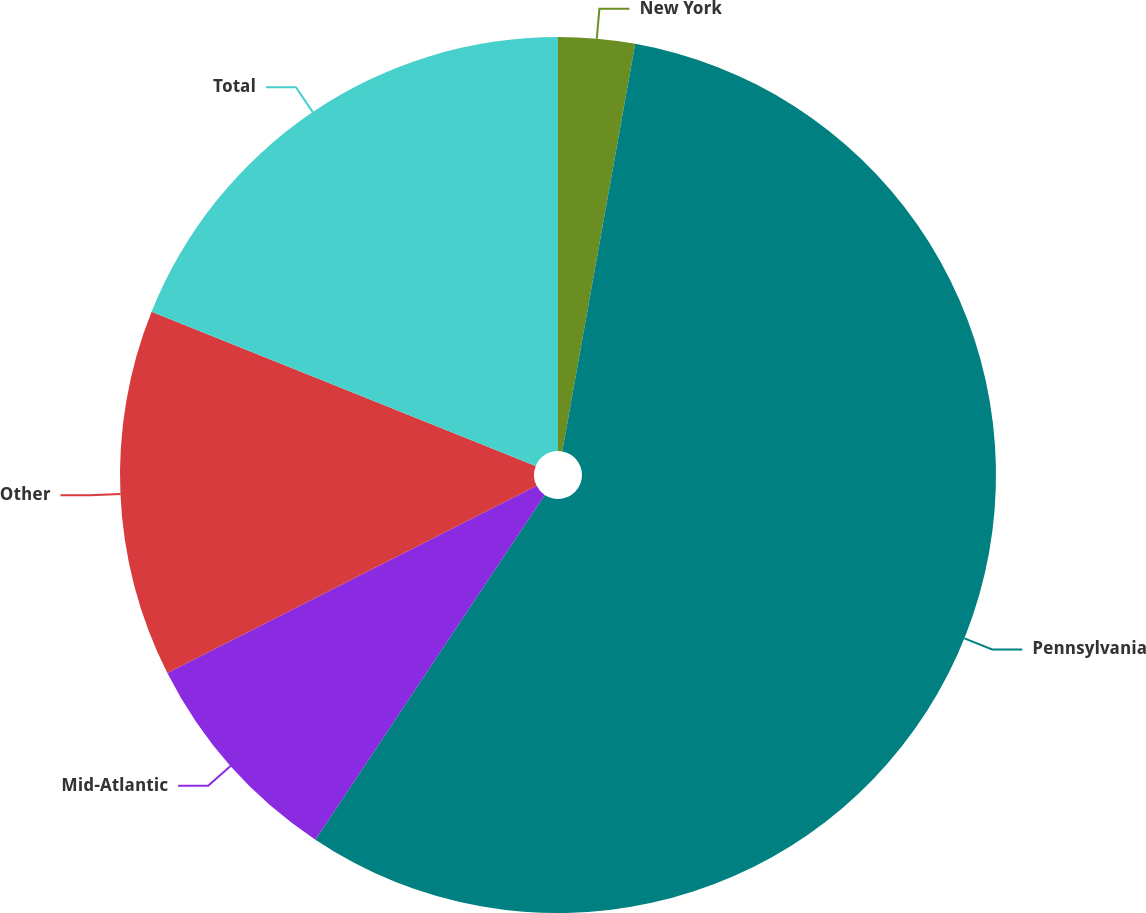Convert chart to OTSL. <chart><loc_0><loc_0><loc_500><loc_500><pie_chart><fcel>New York<fcel>Pennsylvania<fcel>Mid-Atlantic<fcel>Other<fcel>Total<nl><fcel>2.82%<fcel>56.53%<fcel>8.19%<fcel>13.55%<fcel>18.92%<nl></chart> 